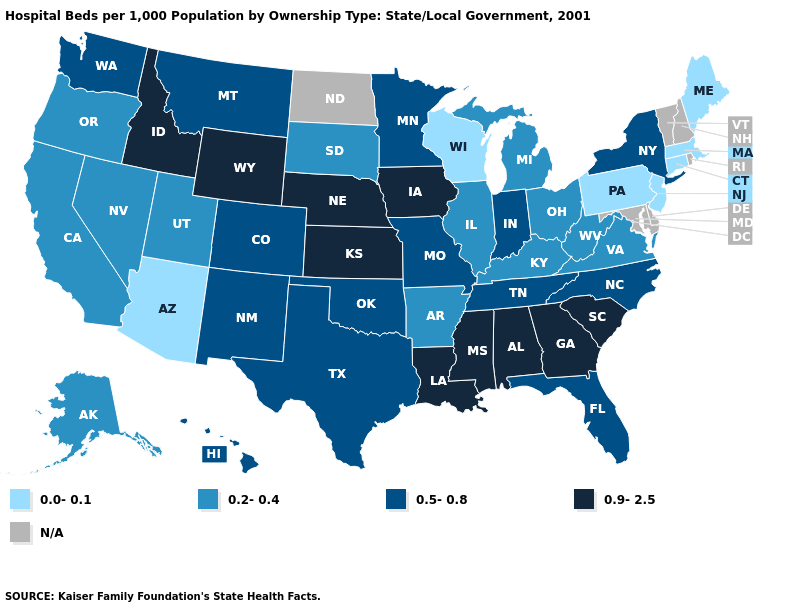What is the lowest value in the Northeast?
Give a very brief answer. 0.0-0.1. What is the value of Nevada?
Answer briefly. 0.2-0.4. Does Massachusetts have the lowest value in the USA?
Write a very short answer. Yes. Name the states that have a value in the range 0.9-2.5?
Be succinct. Alabama, Georgia, Idaho, Iowa, Kansas, Louisiana, Mississippi, Nebraska, South Carolina, Wyoming. Among the states that border Pennsylvania , does West Virginia have the lowest value?
Write a very short answer. No. Which states have the highest value in the USA?
Be succinct. Alabama, Georgia, Idaho, Iowa, Kansas, Louisiana, Mississippi, Nebraska, South Carolina, Wyoming. Name the states that have a value in the range 0.9-2.5?
Concise answer only. Alabama, Georgia, Idaho, Iowa, Kansas, Louisiana, Mississippi, Nebraska, South Carolina, Wyoming. Which states hav the highest value in the MidWest?
Write a very short answer. Iowa, Kansas, Nebraska. What is the value of Missouri?
Be succinct. 0.5-0.8. Name the states that have a value in the range 0.2-0.4?
Quick response, please. Alaska, Arkansas, California, Illinois, Kentucky, Michigan, Nevada, Ohio, Oregon, South Dakota, Utah, Virginia, West Virginia. What is the value of Idaho?
Quick response, please. 0.9-2.5. Which states have the lowest value in the USA?
Be succinct. Arizona, Connecticut, Maine, Massachusetts, New Jersey, Pennsylvania, Wisconsin. 